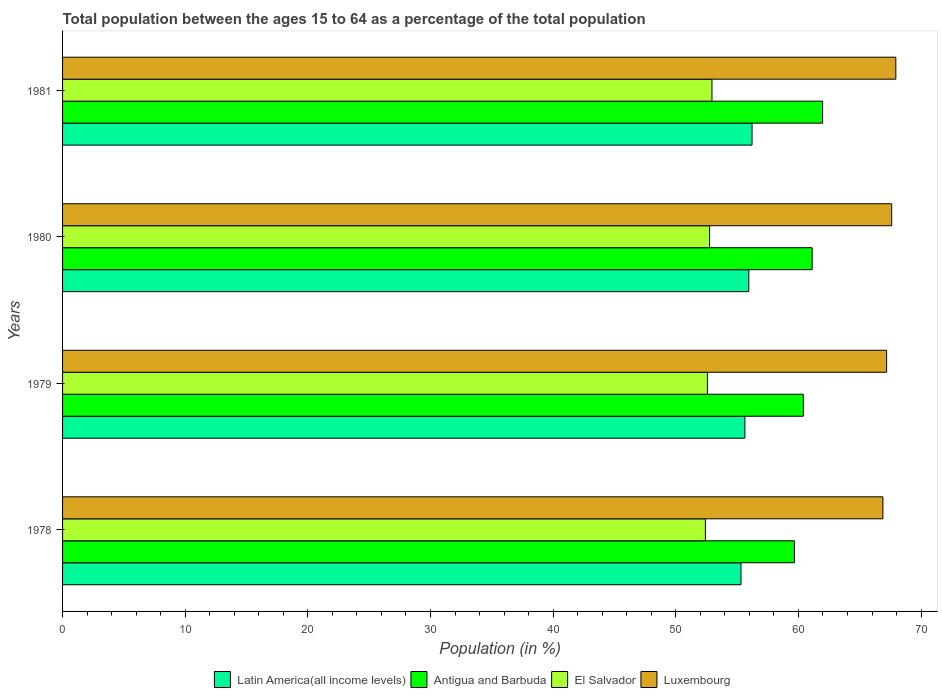Are the number of bars per tick equal to the number of legend labels?
Ensure brevity in your answer.  Yes. How many bars are there on the 2nd tick from the top?
Offer a very short reply. 4. What is the label of the 3rd group of bars from the top?
Make the answer very short. 1979. In how many cases, is the number of bars for a given year not equal to the number of legend labels?
Give a very brief answer. 0. What is the percentage of the population ages 15 to 64 in Antigua and Barbuda in 1981?
Provide a short and direct response. 61.97. Across all years, what is the maximum percentage of the population ages 15 to 64 in Luxembourg?
Keep it short and to the point. 67.94. Across all years, what is the minimum percentage of the population ages 15 to 64 in Luxembourg?
Provide a succinct answer. 66.89. In which year was the percentage of the population ages 15 to 64 in Antigua and Barbuda minimum?
Keep it short and to the point. 1978. What is the total percentage of the population ages 15 to 64 in Antigua and Barbuda in the graph?
Your answer should be very brief. 243.16. What is the difference between the percentage of the population ages 15 to 64 in Luxembourg in 1979 and that in 1981?
Keep it short and to the point. -0.75. What is the difference between the percentage of the population ages 15 to 64 in Antigua and Barbuda in 1979 and the percentage of the population ages 15 to 64 in El Salvador in 1978?
Your answer should be compact. 7.98. What is the average percentage of the population ages 15 to 64 in Latin America(all income levels) per year?
Make the answer very short. 55.78. In the year 1979, what is the difference between the percentage of the population ages 15 to 64 in El Salvador and percentage of the population ages 15 to 64 in Latin America(all income levels)?
Keep it short and to the point. -3.06. In how many years, is the percentage of the population ages 15 to 64 in Antigua and Barbuda greater than 24 ?
Keep it short and to the point. 4. What is the ratio of the percentage of the population ages 15 to 64 in El Salvador in 1978 to that in 1980?
Provide a short and direct response. 0.99. Is the difference between the percentage of the population ages 15 to 64 in El Salvador in 1980 and 1981 greater than the difference between the percentage of the population ages 15 to 64 in Latin America(all income levels) in 1980 and 1981?
Your answer should be compact. Yes. What is the difference between the highest and the second highest percentage of the population ages 15 to 64 in Latin America(all income levels)?
Your answer should be compact. 0.26. What is the difference between the highest and the lowest percentage of the population ages 15 to 64 in Antigua and Barbuda?
Your response must be concise. 2.3. In how many years, is the percentage of the population ages 15 to 64 in Latin America(all income levels) greater than the average percentage of the population ages 15 to 64 in Latin America(all income levels) taken over all years?
Give a very brief answer. 2. Is it the case that in every year, the sum of the percentage of the population ages 15 to 64 in Latin America(all income levels) and percentage of the population ages 15 to 64 in El Salvador is greater than the sum of percentage of the population ages 15 to 64 in Antigua and Barbuda and percentage of the population ages 15 to 64 in Luxembourg?
Offer a terse response. No. What does the 2nd bar from the top in 1979 represents?
Your answer should be very brief. El Salvador. What does the 4th bar from the bottom in 1978 represents?
Provide a short and direct response. Luxembourg. How many bars are there?
Give a very brief answer. 16. Are all the bars in the graph horizontal?
Provide a succinct answer. Yes. What is the difference between two consecutive major ticks on the X-axis?
Make the answer very short. 10. Does the graph contain any zero values?
Keep it short and to the point. No. How are the legend labels stacked?
Your answer should be compact. Horizontal. What is the title of the graph?
Make the answer very short. Total population between the ages 15 to 64 as a percentage of the total population. Does "Bulgaria" appear as one of the legend labels in the graph?
Your response must be concise. No. What is the label or title of the X-axis?
Give a very brief answer. Population (in %). What is the label or title of the Y-axis?
Your response must be concise. Years. What is the Population (in %) of Latin America(all income levels) in 1978?
Your answer should be compact. 55.31. What is the Population (in %) in Antigua and Barbuda in 1978?
Offer a terse response. 59.67. What is the Population (in %) in El Salvador in 1978?
Ensure brevity in your answer.  52.41. What is the Population (in %) in Luxembourg in 1978?
Provide a short and direct response. 66.89. What is the Population (in %) in Latin America(all income levels) in 1979?
Keep it short and to the point. 55.63. What is the Population (in %) in Antigua and Barbuda in 1979?
Keep it short and to the point. 60.4. What is the Population (in %) in El Salvador in 1979?
Keep it short and to the point. 52.58. What is the Population (in %) of Luxembourg in 1979?
Your response must be concise. 67.19. What is the Population (in %) of Latin America(all income levels) in 1980?
Your answer should be compact. 55.95. What is the Population (in %) in Antigua and Barbuda in 1980?
Make the answer very short. 61.12. What is the Population (in %) of El Salvador in 1980?
Your answer should be compact. 52.76. What is the Population (in %) in Luxembourg in 1980?
Provide a succinct answer. 67.6. What is the Population (in %) in Latin America(all income levels) in 1981?
Provide a short and direct response. 56.22. What is the Population (in %) of Antigua and Barbuda in 1981?
Give a very brief answer. 61.97. What is the Population (in %) of El Salvador in 1981?
Your response must be concise. 52.95. What is the Population (in %) in Luxembourg in 1981?
Offer a very short reply. 67.94. Across all years, what is the maximum Population (in %) of Latin America(all income levels)?
Offer a terse response. 56.22. Across all years, what is the maximum Population (in %) in Antigua and Barbuda?
Your answer should be compact. 61.97. Across all years, what is the maximum Population (in %) of El Salvador?
Keep it short and to the point. 52.95. Across all years, what is the maximum Population (in %) of Luxembourg?
Offer a terse response. 67.94. Across all years, what is the minimum Population (in %) of Latin America(all income levels)?
Offer a terse response. 55.31. Across all years, what is the minimum Population (in %) in Antigua and Barbuda?
Provide a succinct answer. 59.67. Across all years, what is the minimum Population (in %) in El Salvador?
Offer a very short reply. 52.41. Across all years, what is the minimum Population (in %) of Luxembourg?
Make the answer very short. 66.89. What is the total Population (in %) of Latin America(all income levels) in the graph?
Provide a short and direct response. 223.12. What is the total Population (in %) in Antigua and Barbuda in the graph?
Your response must be concise. 243.16. What is the total Population (in %) in El Salvador in the graph?
Make the answer very short. 210.7. What is the total Population (in %) of Luxembourg in the graph?
Provide a short and direct response. 269.61. What is the difference between the Population (in %) of Latin America(all income levels) in 1978 and that in 1979?
Keep it short and to the point. -0.32. What is the difference between the Population (in %) in Antigua and Barbuda in 1978 and that in 1979?
Make the answer very short. -0.72. What is the difference between the Population (in %) of El Salvador in 1978 and that in 1979?
Your answer should be compact. -0.17. What is the difference between the Population (in %) in Luxembourg in 1978 and that in 1979?
Offer a very short reply. -0.3. What is the difference between the Population (in %) in Latin America(all income levels) in 1978 and that in 1980?
Provide a succinct answer. -0.64. What is the difference between the Population (in %) in Antigua and Barbuda in 1978 and that in 1980?
Your response must be concise. -1.44. What is the difference between the Population (in %) in El Salvador in 1978 and that in 1980?
Your answer should be compact. -0.34. What is the difference between the Population (in %) of Luxembourg in 1978 and that in 1980?
Your response must be concise. -0.72. What is the difference between the Population (in %) in Latin America(all income levels) in 1978 and that in 1981?
Offer a terse response. -0.9. What is the difference between the Population (in %) in Antigua and Barbuda in 1978 and that in 1981?
Ensure brevity in your answer.  -2.3. What is the difference between the Population (in %) in El Salvador in 1978 and that in 1981?
Your response must be concise. -0.54. What is the difference between the Population (in %) of Luxembourg in 1978 and that in 1981?
Give a very brief answer. -1.05. What is the difference between the Population (in %) in Latin America(all income levels) in 1979 and that in 1980?
Give a very brief answer. -0.32. What is the difference between the Population (in %) of Antigua and Barbuda in 1979 and that in 1980?
Make the answer very short. -0.72. What is the difference between the Population (in %) of El Salvador in 1979 and that in 1980?
Make the answer very short. -0.18. What is the difference between the Population (in %) in Luxembourg in 1979 and that in 1980?
Offer a terse response. -0.41. What is the difference between the Population (in %) in Latin America(all income levels) in 1979 and that in 1981?
Offer a very short reply. -0.58. What is the difference between the Population (in %) of Antigua and Barbuda in 1979 and that in 1981?
Ensure brevity in your answer.  -1.57. What is the difference between the Population (in %) of El Salvador in 1979 and that in 1981?
Provide a succinct answer. -0.37. What is the difference between the Population (in %) in Luxembourg in 1979 and that in 1981?
Your answer should be compact. -0.75. What is the difference between the Population (in %) of Latin America(all income levels) in 1980 and that in 1981?
Give a very brief answer. -0.26. What is the difference between the Population (in %) of Antigua and Barbuda in 1980 and that in 1981?
Make the answer very short. -0.85. What is the difference between the Population (in %) of El Salvador in 1980 and that in 1981?
Provide a succinct answer. -0.19. What is the difference between the Population (in %) of Luxembourg in 1980 and that in 1981?
Your answer should be very brief. -0.34. What is the difference between the Population (in %) of Latin America(all income levels) in 1978 and the Population (in %) of Antigua and Barbuda in 1979?
Make the answer very short. -5.08. What is the difference between the Population (in %) of Latin America(all income levels) in 1978 and the Population (in %) of El Salvador in 1979?
Make the answer very short. 2.74. What is the difference between the Population (in %) of Latin America(all income levels) in 1978 and the Population (in %) of Luxembourg in 1979?
Keep it short and to the point. -11.87. What is the difference between the Population (in %) in Antigua and Barbuda in 1978 and the Population (in %) in El Salvador in 1979?
Ensure brevity in your answer.  7.1. What is the difference between the Population (in %) of Antigua and Barbuda in 1978 and the Population (in %) of Luxembourg in 1979?
Your answer should be very brief. -7.51. What is the difference between the Population (in %) in El Salvador in 1978 and the Population (in %) in Luxembourg in 1979?
Provide a short and direct response. -14.77. What is the difference between the Population (in %) of Latin America(all income levels) in 1978 and the Population (in %) of Antigua and Barbuda in 1980?
Ensure brevity in your answer.  -5.8. What is the difference between the Population (in %) of Latin America(all income levels) in 1978 and the Population (in %) of El Salvador in 1980?
Your response must be concise. 2.56. What is the difference between the Population (in %) in Latin America(all income levels) in 1978 and the Population (in %) in Luxembourg in 1980?
Your answer should be very brief. -12.29. What is the difference between the Population (in %) of Antigua and Barbuda in 1978 and the Population (in %) of El Salvador in 1980?
Ensure brevity in your answer.  6.92. What is the difference between the Population (in %) of Antigua and Barbuda in 1978 and the Population (in %) of Luxembourg in 1980?
Your response must be concise. -7.93. What is the difference between the Population (in %) of El Salvador in 1978 and the Population (in %) of Luxembourg in 1980?
Your answer should be compact. -15.19. What is the difference between the Population (in %) in Latin America(all income levels) in 1978 and the Population (in %) in Antigua and Barbuda in 1981?
Provide a short and direct response. -6.66. What is the difference between the Population (in %) in Latin America(all income levels) in 1978 and the Population (in %) in El Salvador in 1981?
Ensure brevity in your answer.  2.37. What is the difference between the Population (in %) in Latin America(all income levels) in 1978 and the Population (in %) in Luxembourg in 1981?
Your answer should be compact. -12.63. What is the difference between the Population (in %) in Antigua and Barbuda in 1978 and the Population (in %) in El Salvador in 1981?
Your answer should be very brief. 6.73. What is the difference between the Population (in %) in Antigua and Barbuda in 1978 and the Population (in %) in Luxembourg in 1981?
Provide a short and direct response. -8.27. What is the difference between the Population (in %) in El Salvador in 1978 and the Population (in %) in Luxembourg in 1981?
Offer a terse response. -15.53. What is the difference between the Population (in %) in Latin America(all income levels) in 1979 and the Population (in %) in Antigua and Barbuda in 1980?
Keep it short and to the point. -5.48. What is the difference between the Population (in %) in Latin America(all income levels) in 1979 and the Population (in %) in El Salvador in 1980?
Provide a succinct answer. 2.88. What is the difference between the Population (in %) of Latin America(all income levels) in 1979 and the Population (in %) of Luxembourg in 1980?
Your answer should be compact. -11.97. What is the difference between the Population (in %) in Antigua and Barbuda in 1979 and the Population (in %) in El Salvador in 1980?
Provide a succinct answer. 7.64. What is the difference between the Population (in %) of Antigua and Barbuda in 1979 and the Population (in %) of Luxembourg in 1980?
Keep it short and to the point. -7.21. What is the difference between the Population (in %) in El Salvador in 1979 and the Population (in %) in Luxembourg in 1980?
Keep it short and to the point. -15.02. What is the difference between the Population (in %) of Latin America(all income levels) in 1979 and the Population (in %) of Antigua and Barbuda in 1981?
Give a very brief answer. -6.34. What is the difference between the Population (in %) of Latin America(all income levels) in 1979 and the Population (in %) of El Salvador in 1981?
Your answer should be compact. 2.69. What is the difference between the Population (in %) of Latin America(all income levels) in 1979 and the Population (in %) of Luxembourg in 1981?
Provide a succinct answer. -12.31. What is the difference between the Population (in %) of Antigua and Barbuda in 1979 and the Population (in %) of El Salvador in 1981?
Provide a short and direct response. 7.45. What is the difference between the Population (in %) of Antigua and Barbuda in 1979 and the Population (in %) of Luxembourg in 1981?
Offer a terse response. -7.54. What is the difference between the Population (in %) in El Salvador in 1979 and the Population (in %) in Luxembourg in 1981?
Offer a terse response. -15.36. What is the difference between the Population (in %) of Latin America(all income levels) in 1980 and the Population (in %) of Antigua and Barbuda in 1981?
Ensure brevity in your answer.  -6.02. What is the difference between the Population (in %) of Latin America(all income levels) in 1980 and the Population (in %) of El Salvador in 1981?
Provide a short and direct response. 3. What is the difference between the Population (in %) in Latin America(all income levels) in 1980 and the Population (in %) in Luxembourg in 1981?
Provide a short and direct response. -11.99. What is the difference between the Population (in %) of Antigua and Barbuda in 1980 and the Population (in %) of El Salvador in 1981?
Ensure brevity in your answer.  8.17. What is the difference between the Population (in %) in Antigua and Barbuda in 1980 and the Population (in %) in Luxembourg in 1981?
Keep it short and to the point. -6.82. What is the difference between the Population (in %) in El Salvador in 1980 and the Population (in %) in Luxembourg in 1981?
Ensure brevity in your answer.  -15.18. What is the average Population (in %) in Latin America(all income levels) per year?
Offer a very short reply. 55.78. What is the average Population (in %) of Antigua and Barbuda per year?
Provide a succinct answer. 60.79. What is the average Population (in %) of El Salvador per year?
Offer a very short reply. 52.67. What is the average Population (in %) in Luxembourg per year?
Your answer should be very brief. 67.4. In the year 1978, what is the difference between the Population (in %) of Latin America(all income levels) and Population (in %) of Antigua and Barbuda?
Keep it short and to the point. -4.36. In the year 1978, what is the difference between the Population (in %) in Latin America(all income levels) and Population (in %) in El Salvador?
Provide a succinct answer. 2.9. In the year 1978, what is the difference between the Population (in %) of Latin America(all income levels) and Population (in %) of Luxembourg?
Keep it short and to the point. -11.57. In the year 1978, what is the difference between the Population (in %) in Antigua and Barbuda and Population (in %) in El Salvador?
Offer a very short reply. 7.26. In the year 1978, what is the difference between the Population (in %) of Antigua and Barbuda and Population (in %) of Luxembourg?
Your response must be concise. -7.21. In the year 1978, what is the difference between the Population (in %) in El Salvador and Population (in %) in Luxembourg?
Offer a very short reply. -14.47. In the year 1979, what is the difference between the Population (in %) in Latin America(all income levels) and Population (in %) in Antigua and Barbuda?
Offer a very short reply. -4.76. In the year 1979, what is the difference between the Population (in %) in Latin America(all income levels) and Population (in %) in El Salvador?
Your response must be concise. 3.06. In the year 1979, what is the difference between the Population (in %) of Latin America(all income levels) and Population (in %) of Luxembourg?
Provide a succinct answer. -11.55. In the year 1979, what is the difference between the Population (in %) of Antigua and Barbuda and Population (in %) of El Salvador?
Give a very brief answer. 7.82. In the year 1979, what is the difference between the Population (in %) in Antigua and Barbuda and Population (in %) in Luxembourg?
Your response must be concise. -6.79. In the year 1979, what is the difference between the Population (in %) of El Salvador and Population (in %) of Luxembourg?
Give a very brief answer. -14.61. In the year 1980, what is the difference between the Population (in %) in Latin America(all income levels) and Population (in %) in Antigua and Barbuda?
Ensure brevity in your answer.  -5.17. In the year 1980, what is the difference between the Population (in %) in Latin America(all income levels) and Population (in %) in El Salvador?
Offer a very short reply. 3.2. In the year 1980, what is the difference between the Population (in %) in Latin America(all income levels) and Population (in %) in Luxembourg?
Offer a terse response. -11.65. In the year 1980, what is the difference between the Population (in %) in Antigua and Barbuda and Population (in %) in El Salvador?
Ensure brevity in your answer.  8.36. In the year 1980, what is the difference between the Population (in %) in Antigua and Barbuda and Population (in %) in Luxembourg?
Give a very brief answer. -6.48. In the year 1980, what is the difference between the Population (in %) in El Salvador and Population (in %) in Luxembourg?
Ensure brevity in your answer.  -14.84. In the year 1981, what is the difference between the Population (in %) of Latin America(all income levels) and Population (in %) of Antigua and Barbuda?
Make the answer very short. -5.75. In the year 1981, what is the difference between the Population (in %) of Latin America(all income levels) and Population (in %) of El Salvador?
Ensure brevity in your answer.  3.27. In the year 1981, what is the difference between the Population (in %) of Latin America(all income levels) and Population (in %) of Luxembourg?
Your response must be concise. -11.72. In the year 1981, what is the difference between the Population (in %) in Antigua and Barbuda and Population (in %) in El Salvador?
Ensure brevity in your answer.  9.02. In the year 1981, what is the difference between the Population (in %) of Antigua and Barbuda and Population (in %) of Luxembourg?
Offer a terse response. -5.97. In the year 1981, what is the difference between the Population (in %) of El Salvador and Population (in %) of Luxembourg?
Provide a succinct answer. -14.99. What is the ratio of the Population (in %) in Antigua and Barbuda in 1978 to that in 1979?
Ensure brevity in your answer.  0.99. What is the ratio of the Population (in %) in El Salvador in 1978 to that in 1979?
Make the answer very short. 1. What is the ratio of the Population (in %) of Luxembourg in 1978 to that in 1979?
Offer a very short reply. 1. What is the ratio of the Population (in %) in Antigua and Barbuda in 1978 to that in 1980?
Provide a succinct answer. 0.98. What is the ratio of the Population (in %) of El Salvador in 1978 to that in 1980?
Provide a succinct answer. 0.99. What is the ratio of the Population (in %) of Luxembourg in 1978 to that in 1980?
Offer a terse response. 0.99. What is the ratio of the Population (in %) in Antigua and Barbuda in 1978 to that in 1981?
Your answer should be very brief. 0.96. What is the ratio of the Population (in %) in El Salvador in 1978 to that in 1981?
Offer a terse response. 0.99. What is the ratio of the Population (in %) in Luxembourg in 1978 to that in 1981?
Provide a succinct answer. 0.98. What is the ratio of the Population (in %) in El Salvador in 1979 to that in 1980?
Provide a succinct answer. 1. What is the ratio of the Population (in %) in Luxembourg in 1979 to that in 1980?
Offer a terse response. 0.99. What is the ratio of the Population (in %) in Latin America(all income levels) in 1979 to that in 1981?
Provide a succinct answer. 0.99. What is the ratio of the Population (in %) in Antigua and Barbuda in 1979 to that in 1981?
Provide a short and direct response. 0.97. What is the ratio of the Population (in %) of Luxembourg in 1979 to that in 1981?
Your answer should be very brief. 0.99. What is the ratio of the Population (in %) in Latin America(all income levels) in 1980 to that in 1981?
Provide a succinct answer. 1. What is the ratio of the Population (in %) of Antigua and Barbuda in 1980 to that in 1981?
Make the answer very short. 0.99. What is the ratio of the Population (in %) in El Salvador in 1980 to that in 1981?
Your answer should be compact. 1. What is the ratio of the Population (in %) in Luxembourg in 1980 to that in 1981?
Make the answer very short. 0.99. What is the difference between the highest and the second highest Population (in %) of Latin America(all income levels)?
Provide a succinct answer. 0.26. What is the difference between the highest and the second highest Population (in %) of Antigua and Barbuda?
Give a very brief answer. 0.85. What is the difference between the highest and the second highest Population (in %) of El Salvador?
Provide a succinct answer. 0.19. What is the difference between the highest and the second highest Population (in %) of Luxembourg?
Keep it short and to the point. 0.34. What is the difference between the highest and the lowest Population (in %) of Latin America(all income levels)?
Offer a terse response. 0.9. What is the difference between the highest and the lowest Population (in %) of Antigua and Barbuda?
Offer a very short reply. 2.3. What is the difference between the highest and the lowest Population (in %) of El Salvador?
Offer a terse response. 0.54. What is the difference between the highest and the lowest Population (in %) in Luxembourg?
Your answer should be very brief. 1.05. 